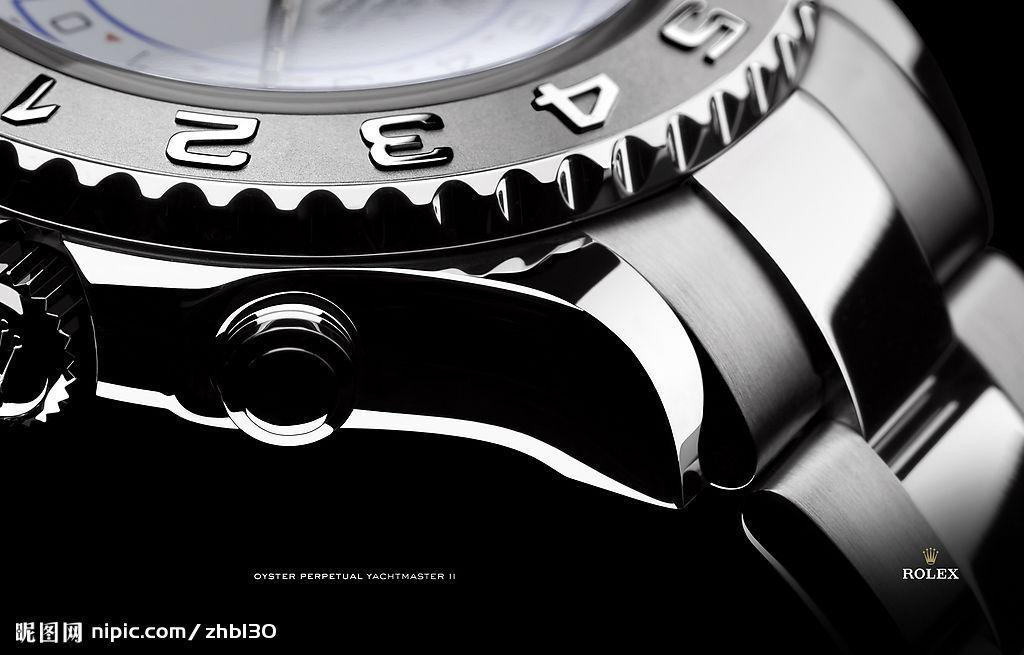<image>
Create a compact narrative representing the image presented. Face of a black watch with the word ROLEX near the bottom. 